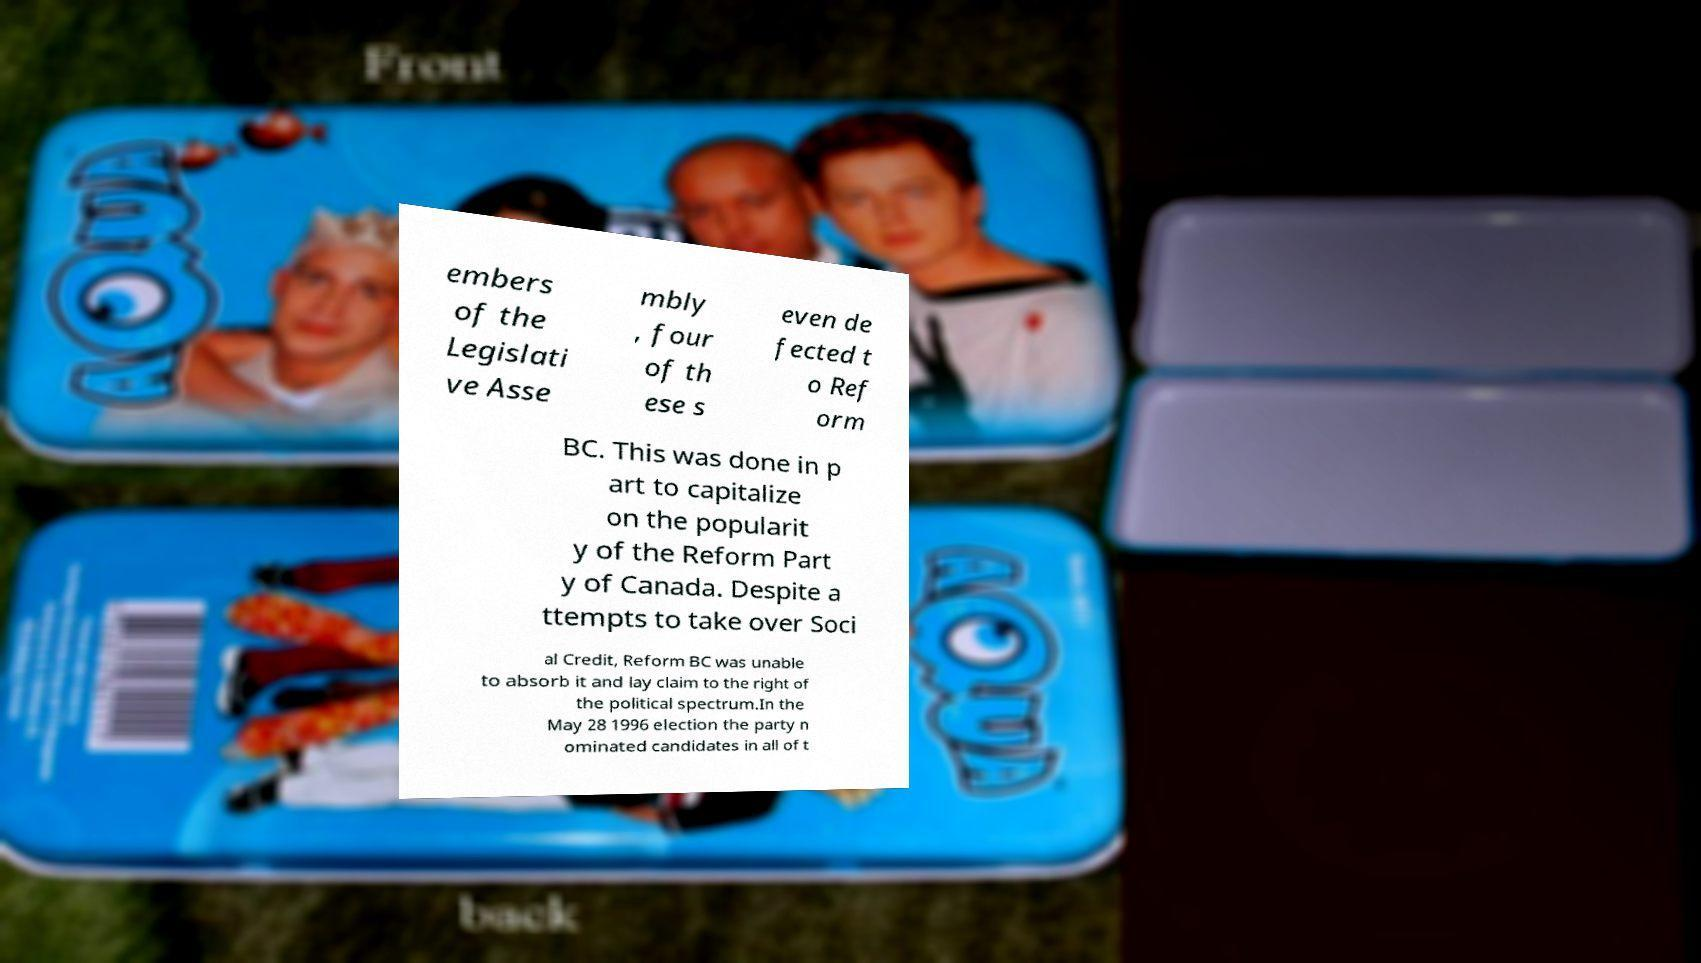Could you assist in decoding the text presented in this image and type it out clearly? embers of the Legislati ve Asse mbly , four of th ese s even de fected t o Ref orm BC. This was done in p art to capitalize on the popularit y of the Reform Part y of Canada. Despite a ttempts to take over Soci al Credit, Reform BC was unable to absorb it and lay claim to the right of the political spectrum.In the May 28 1996 election the party n ominated candidates in all of t 